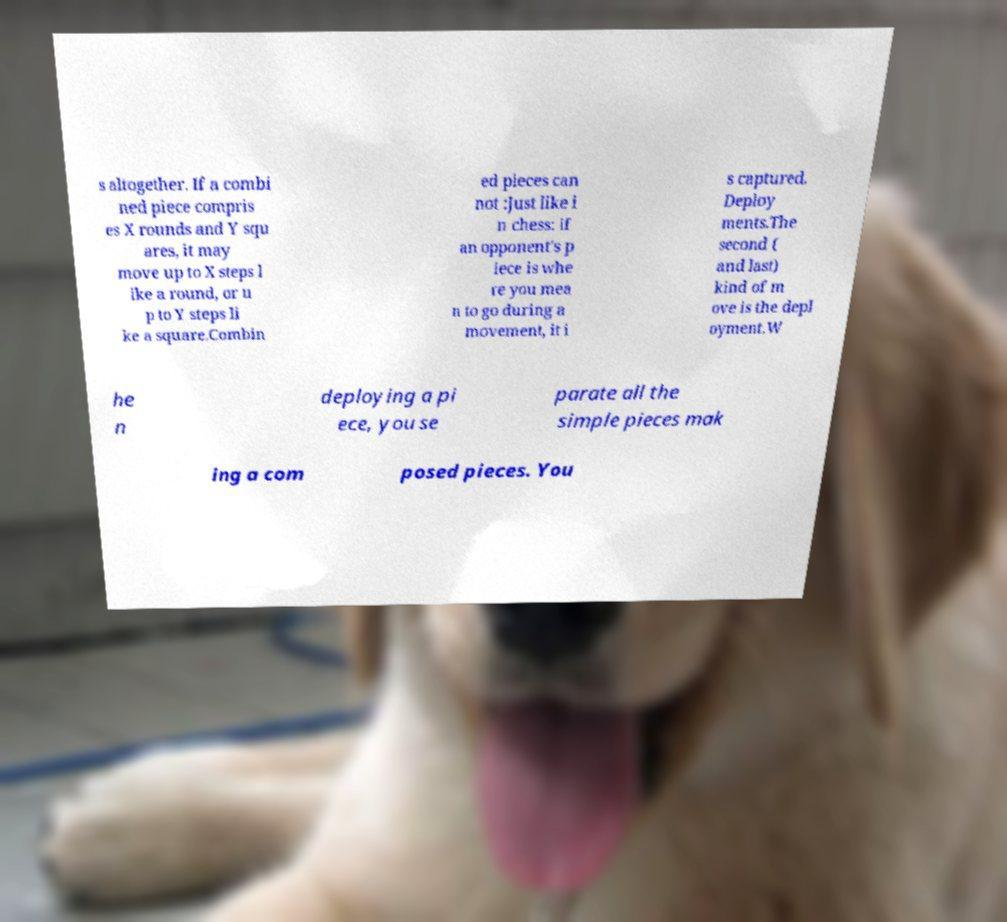Could you extract and type out the text from this image? s altogether. If a combi ned piece compris es X rounds and Y squ ares, it may move up to X steps l ike a round, or u p to Y steps li ke a square.Combin ed pieces can not :Just like i n chess: if an opponent's p iece is whe re you mea n to go during a movement, it i s captured. Deploy ments.The second ( and last) kind of m ove is the depl oyment.W he n deploying a pi ece, you se parate all the simple pieces mak ing a com posed pieces. You 